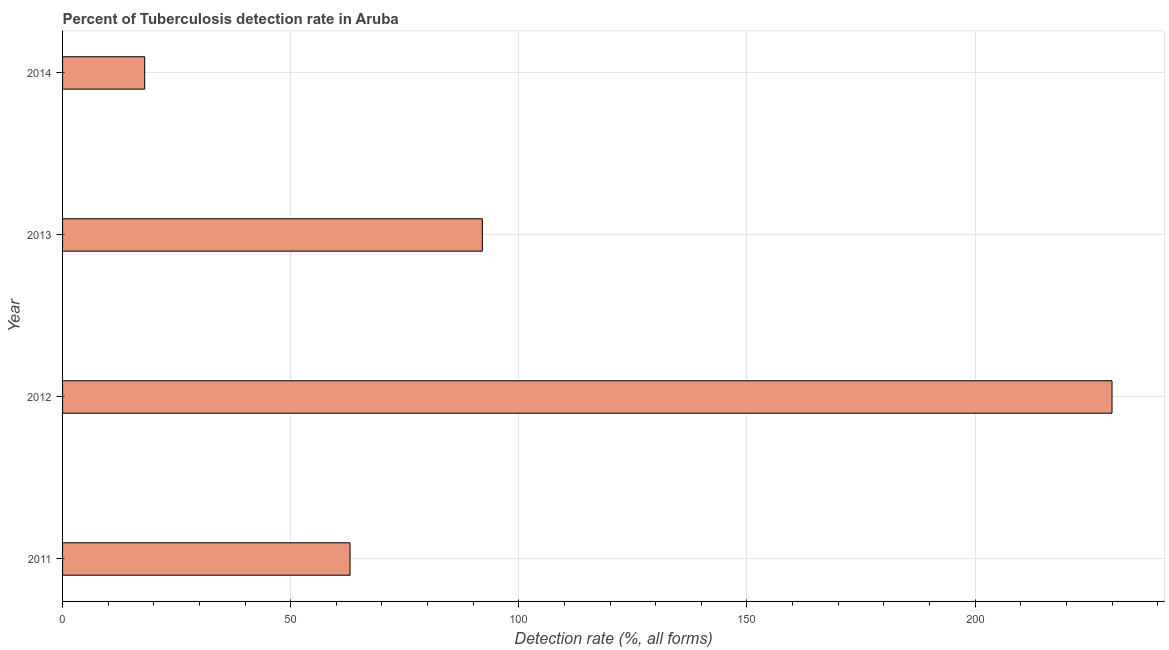What is the title of the graph?
Keep it short and to the point. Percent of Tuberculosis detection rate in Aruba. What is the label or title of the X-axis?
Your response must be concise. Detection rate (%, all forms). What is the label or title of the Y-axis?
Give a very brief answer. Year. What is the detection rate of tuberculosis in 2012?
Provide a succinct answer. 230. Across all years, what is the maximum detection rate of tuberculosis?
Give a very brief answer. 230. Across all years, what is the minimum detection rate of tuberculosis?
Your answer should be very brief. 18. What is the sum of the detection rate of tuberculosis?
Ensure brevity in your answer.  403. What is the difference between the detection rate of tuberculosis in 2013 and 2014?
Provide a succinct answer. 74. What is the average detection rate of tuberculosis per year?
Give a very brief answer. 100. What is the median detection rate of tuberculosis?
Make the answer very short. 77.5. In how many years, is the detection rate of tuberculosis greater than 150 %?
Make the answer very short. 1. Do a majority of the years between 2014 and 2012 (inclusive) have detection rate of tuberculosis greater than 130 %?
Offer a very short reply. Yes. What is the ratio of the detection rate of tuberculosis in 2012 to that in 2013?
Your answer should be very brief. 2.5. Is the detection rate of tuberculosis in 2011 less than that in 2014?
Your answer should be very brief. No. What is the difference between the highest and the second highest detection rate of tuberculosis?
Offer a terse response. 138. What is the difference between the highest and the lowest detection rate of tuberculosis?
Offer a terse response. 212. How many years are there in the graph?
Offer a very short reply. 4. What is the Detection rate (%, all forms) in 2011?
Your answer should be compact. 63. What is the Detection rate (%, all forms) of 2012?
Your answer should be compact. 230. What is the Detection rate (%, all forms) in 2013?
Keep it short and to the point. 92. What is the difference between the Detection rate (%, all forms) in 2011 and 2012?
Your answer should be very brief. -167. What is the difference between the Detection rate (%, all forms) in 2011 and 2014?
Your response must be concise. 45. What is the difference between the Detection rate (%, all forms) in 2012 and 2013?
Your answer should be compact. 138. What is the difference between the Detection rate (%, all forms) in 2012 and 2014?
Your answer should be very brief. 212. What is the difference between the Detection rate (%, all forms) in 2013 and 2014?
Offer a terse response. 74. What is the ratio of the Detection rate (%, all forms) in 2011 to that in 2012?
Keep it short and to the point. 0.27. What is the ratio of the Detection rate (%, all forms) in 2011 to that in 2013?
Your answer should be very brief. 0.69. What is the ratio of the Detection rate (%, all forms) in 2012 to that in 2014?
Your response must be concise. 12.78. What is the ratio of the Detection rate (%, all forms) in 2013 to that in 2014?
Your response must be concise. 5.11. 